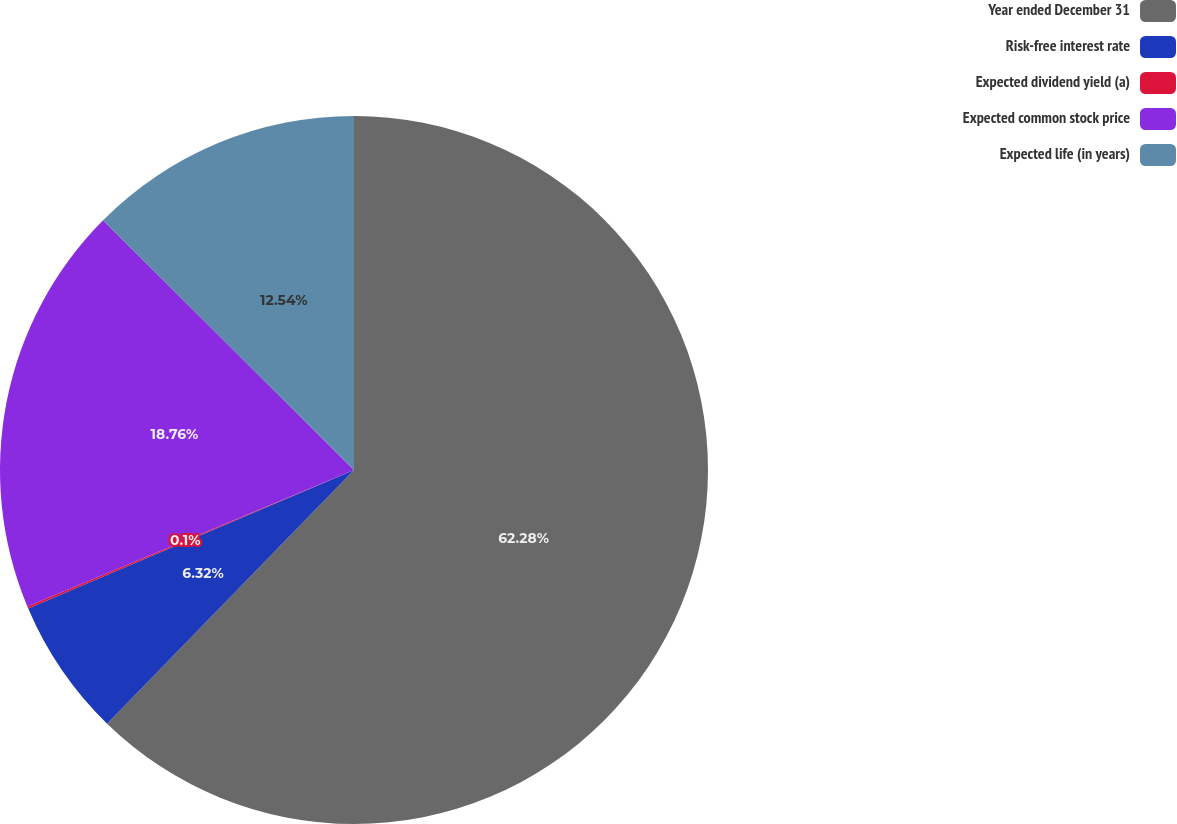Convert chart. <chart><loc_0><loc_0><loc_500><loc_500><pie_chart><fcel>Year ended December 31<fcel>Risk-free interest rate<fcel>Expected dividend yield (a)<fcel>Expected common stock price<fcel>Expected life (in years)<nl><fcel>62.29%<fcel>6.32%<fcel>0.1%<fcel>18.76%<fcel>12.54%<nl></chart> 